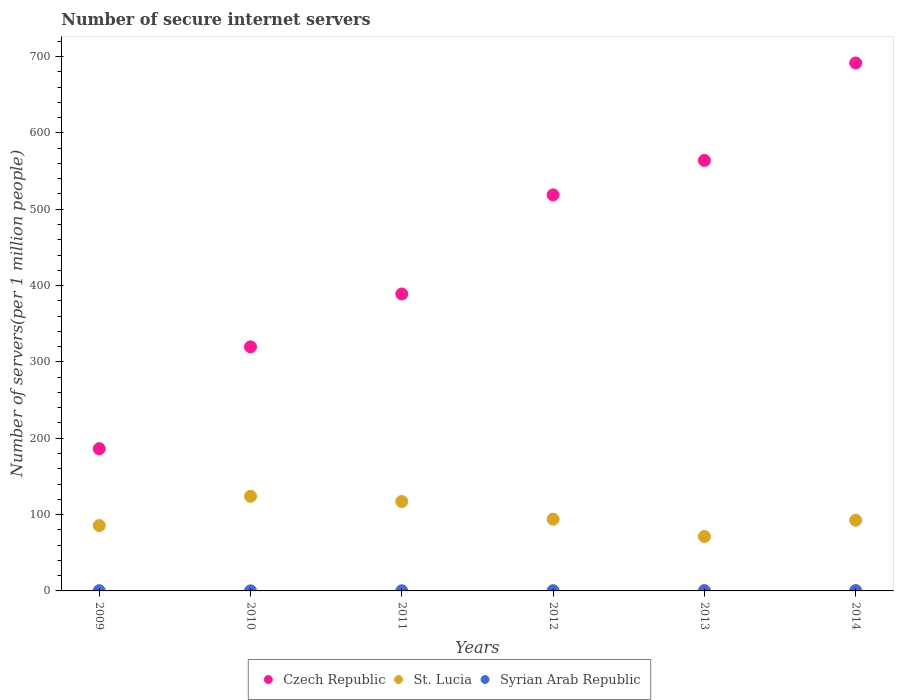Is the number of dotlines equal to the number of legend labels?
Provide a succinct answer. Yes. What is the number of secure internet servers in Czech Republic in 2013?
Offer a terse response. 563.9. Across all years, what is the maximum number of secure internet servers in Syrian Arab Republic?
Make the answer very short. 0.5. Across all years, what is the minimum number of secure internet servers in Syrian Arab Republic?
Your answer should be very brief. 0.1. In which year was the number of secure internet servers in Czech Republic maximum?
Your answer should be very brief. 2014. In which year was the number of secure internet servers in St. Lucia minimum?
Offer a terse response. 2013. What is the total number of secure internet servers in Czech Republic in the graph?
Offer a terse response. 2669.35. What is the difference between the number of secure internet servers in Czech Republic in 2011 and that in 2013?
Your response must be concise. -174.9. What is the difference between the number of secure internet servers in St. Lucia in 2014 and the number of secure internet servers in Czech Republic in 2010?
Ensure brevity in your answer.  -227.16. What is the average number of secure internet servers in St. Lucia per year?
Ensure brevity in your answer.  97.44. In the year 2014, what is the difference between the number of secure internet servers in St. Lucia and number of secure internet servers in Czech Republic?
Give a very brief answer. -599.02. What is the ratio of the number of secure internet servers in Syrian Arab Republic in 2012 to that in 2013?
Make the answer very short. 0.81. Is the number of secure internet servers in Czech Republic in 2009 less than that in 2014?
Your answer should be compact. Yes. What is the difference between the highest and the second highest number of secure internet servers in Czech Republic?
Your response must be concise. 127.69. What is the difference between the highest and the lowest number of secure internet servers in St. Lucia?
Offer a terse response. 52.71. In how many years, is the number of secure internet servers in Syrian Arab Republic greater than the average number of secure internet servers in Syrian Arab Republic taken over all years?
Ensure brevity in your answer.  4. Is the sum of the number of secure internet servers in Czech Republic in 2010 and 2011 greater than the maximum number of secure internet servers in Syrian Arab Republic across all years?
Your answer should be very brief. Yes. Is it the case that in every year, the sum of the number of secure internet servers in Czech Republic and number of secure internet servers in St. Lucia  is greater than the number of secure internet servers in Syrian Arab Republic?
Keep it short and to the point. Yes. Does the number of secure internet servers in Czech Republic monotonically increase over the years?
Provide a short and direct response. Yes. Is the number of secure internet servers in Syrian Arab Republic strictly less than the number of secure internet servers in St. Lucia over the years?
Provide a short and direct response. Yes. What is the difference between two consecutive major ticks on the Y-axis?
Offer a terse response. 100. Does the graph contain any zero values?
Offer a terse response. No. How many legend labels are there?
Give a very brief answer. 3. What is the title of the graph?
Offer a terse response. Number of secure internet servers. What is the label or title of the X-axis?
Your answer should be very brief. Years. What is the label or title of the Y-axis?
Provide a short and direct response. Number of servers(per 1 million people). What is the Number of servers(per 1 million people) of Czech Republic in 2009?
Offer a terse response. 186.33. What is the Number of servers(per 1 million people) of St. Lucia in 2009?
Your answer should be compact. 85.62. What is the Number of servers(per 1 million people) in Syrian Arab Republic in 2009?
Make the answer very short. 0.34. What is the Number of servers(per 1 million people) of Czech Republic in 2010?
Make the answer very short. 319.73. What is the Number of servers(per 1 million people) in St. Lucia in 2010?
Make the answer very short. 124.02. What is the Number of servers(per 1 million people) in Syrian Arab Republic in 2010?
Ensure brevity in your answer.  0.1. What is the Number of servers(per 1 million people) in Czech Republic in 2011?
Offer a very short reply. 389. What is the Number of servers(per 1 million people) of St. Lucia in 2011?
Offer a terse response. 117.14. What is the Number of servers(per 1 million people) in Syrian Arab Republic in 2011?
Provide a succinct answer. 0.24. What is the Number of servers(per 1 million people) of Czech Republic in 2012?
Your response must be concise. 518.8. What is the Number of servers(per 1 million people) of St. Lucia in 2012?
Keep it short and to the point. 93.98. What is the Number of servers(per 1 million people) of Syrian Arab Republic in 2012?
Your answer should be compact. 0.37. What is the Number of servers(per 1 million people) in Czech Republic in 2013?
Your answer should be very brief. 563.9. What is the Number of servers(per 1 million people) in St. Lucia in 2013?
Ensure brevity in your answer.  71.31. What is the Number of servers(per 1 million people) of Syrian Arab Republic in 2013?
Give a very brief answer. 0.46. What is the Number of servers(per 1 million people) of Czech Republic in 2014?
Keep it short and to the point. 691.59. What is the Number of servers(per 1 million people) in St. Lucia in 2014?
Make the answer very short. 92.57. What is the Number of servers(per 1 million people) in Syrian Arab Republic in 2014?
Give a very brief answer. 0.5. Across all years, what is the maximum Number of servers(per 1 million people) of Czech Republic?
Your response must be concise. 691.59. Across all years, what is the maximum Number of servers(per 1 million people) of St. Lucia?
Ensure brevity in your answer.  124.02. Across all years, what is the maximum Number of servers(per 1 million people) of Syrian Arab Republic?
Offer a terse response. 0.5. Across all years, what is the minimum Number of servers(per 1 million people) in Czech Republic?
Provide a succinct answer. 186.33. Across all years, what is the minimum Number of servers(per 1 million people) of St. Lucia?
Offer a terse response. 71.31. Across all years, what is the minimum Number of servers(per 1 million people) of Syrian Arab Republic?
Ensure brevity in your answer.  0.1. What is the total Number of servers(per 1 million people) of Czech Republic in the graph?
Offer a very short reply. 2669.35. What is the total Number of servers(per 1 million people) of St. Lucia in the graph?
Offer a very short reply. 584.63. What is the total Number of servers(per 1 million people) of Syrian Arab Republic in the graph?
Provide a short and direct response. 2. What is the difference between the Number of servers(per 1 million people) in Czech Republic in 2009 and that in 2010?
Your answer should be compact. -133.4. What is the difference between the Number of servers(per 1 million people) of St. Lucia in 2009 and that in 2010?
Give a very brief answer. -38.4. What is the difference between the Number of servers(per 1 million people) of Syrian Arab Republic in 2009 and that in 2010?
Give a very brief answer. 0.24. What is the difference between the Number of servers(per 1 million people) of Czech Republic in 2009 and that in 2011?
Offer a terse response. -202.67. What is the difference between the Number of servers(per 1 million people) in St. Lucia in 2009 and that in 2011?
Provide a short and direct response. -31.52. What is the difference between the Number of servers(per 1 million people) of Syrian Arab Republic in 2009 and that in 2011?
Provide a succinct answer. 0.1. What is the difference between the Number of servers(per 1 million people) of Czech Republic in 2009 and that in 2012?
Keep it short and to the point. -332.47. What is the difference between the Number of servers(per 1 million people) of St. Lucia in 2009 and that in 2012?
Offer a very short reply. -8.36. What is the difference between the Number of servers(per 1 million people) in Syrian Arab Republic in 2009 and that in 2012?
Your answer should be very brief. -0.03. What is the difference between the Number of servers(per 1 million people) in Czech Republic in 2009 and that in 2013?
Ensure brevity in your answer.  -377.57. What is the difference between the Number of servers(per 1 million people) in St. Lucia in 2009 and that in 2013?
Provide a short and direct response. 14.31. What is the difference between the Number of servers(per 1 million people) in Syrian Arab Republic in 2009 and that in 2013?
Your response must be concise. -0.12. What is the difference between the Number of servers(per 1 million people) of Czech Republic in 2009 and that in 2014?
Give a very brief answer. -505.26. What is the difference between the Number of servers(per 1 million people) in St. Lucia in 2009 and that in 2014?
Provide a short and direct response. -6.95. What is the difference between the Number of servers(per 1 million people) of Syrian Arab Republic in 2009 and that in 2014?
Offer a terse response. -0.16. What is the difference between the Number of servers(per 1 million people) in Czech Republic in 2010 and that in 2011?
Provide a succinct answer. -69.27. What is the difference between the Number of servers(per 1 million people) of St. Lucia in 2010 and that in 2011?
Your answer should be compact. 6.88. What is the difference between the Number of servers(per 1 million people) of Syrian Arab Republic in 2010 and that in 2011?
Ensure brevity in your answer.  -0.14. What is the difference between the Number of servers(per 1 million people) in Czech Republic in 2010 and that in 2012?
Ensure brevity in your answer.  -199.07. What is the difference between the Number of servers(per 1 million people) in St. Lucia in 2010 and that in 2012?
Offer a terse response. 30.04. What is the difference between the Number of servers(per 1 million people) of Syrian Arab Republic in 2010 and that in 2012?
Your response must be concise. -0.28. What is the difference between the Number of servers(per 1 million people) in Czech Republic in 2010 and that in 2013?
Provide a succinct answer. -244.17. What is the difference between the Number of servers(per 1 million people) in St. Lucia in 2010 and that in 2013?
Provide a succinct answer. 52.71. What is the difference between the Number of servers(per 1 million people) of Syrian Arab Republic in 2010 and that in 2013?
Keep it short and to the point. -0.36. What is the difference between the Number of servers(per 1 million people) in Czech Republic in 2010 and that in 2014?
Ensure brevity in your answer.  -371.86. What is the difference between the Number of servers(per 1 million people) of St. Lucia in 2010 and that in 2014?
Make the answer very short. 31.45. What is the difference between the Number of servers(per 1 million people) of Syrian Arab Republic in 2010 and that in 2014?
Offer a terse response. -0.4. What is the difference between the Number of servers(per 1 million people) in Czech Republic in 2011 and that in 2012?
Provide a short and direct response. -129.8. What is the difference between the Number of servers(per 1 million people) in St. Lucia in 2011 and that in 2012?
Provide a short and direct response. 23.16. What is the difference between the Number of servers(per 1 million people) of Syrian Arab Republic in 2011 and that in 2012?
Offer a terse response. -0.14. What is the difference between the Number of servers(per 1 million people) in Czech Republic in 2011 and that in 2013?
Offer a very short reply. -174.9. What is the difference between the Number of servers(per 1 million people) of St. Lucia in 2011 and that in 2013?
Keep it short and to the point. 45.83. What is the difference between the Number of servers(per 1 million people) in Syrian Arab Republic in 2011 and that in 2013?
Provide a short and direct response. -0.22. What is the difference between the Number of servers(per 1 million people) of Czech Republic in 2011 and that in 2014?
Offer a terse response. -302.59. What is the difference between the Number of servers(per 1 million people) in St. Lucia in 2011 and that in 2014?
Your answer should be very brief. 24.57. What is the difference between the Number of servers(per 1 million people) of Syrian Arab Republic in 2011 and that in 2014?
Your answer should be compact. -0.26. What is the difference between the Number of servers(per 1 million people) of Czech Republic in 2012 and that in 2013?
Provide a succinct answer. -45.1. What is the difference between the Number of servers(per 1 million people) of St. Lucia in 2012 and that in 2013?
Offer a terse response. 22.67. What is the difference between the Number of servers(per 1 million people) in Syrian Arab Republic in 2012 and that in 2013?
Your answer should be compact. -0.09. What is the difference between the Number of servers(per 1 million people) of Czech Republic in 2012 and that in 2014?
Provide a succinct answer. -172.79. What is the difference between the Number of servers(per 1 million people) in St. Lucia in 2012 and that in 2014?
Your response must be concise. 1.41. What is the difference between the Number of servers(per 1 million people) in Syrian Arab Republic in 2012 and that in 2014?
Provide a short and direct response. -0.12. What is the difference between the Number of servers(per 1 million people) in Czech Republic in 2013 and that in 2014?
Give a very brief answer. -127.69. What is the difference between the Number of servers(per 1 million people) of St. Lucia in 2013 and that in 2014?
Ensure brevity in your answer.  -21.26. What is the difference between the Number of servers(per 1 million people) of Syrian Arab Republic in 2013 and that in 2014?
Make the answer very short. -0.04. What is the difference between the Number of servers(per 1 million people) in Czech Republic in 2009 and the Number of servers(per 1 million people) in St. Lucia in 2010?
Ensure brevity in your answer.  62.31. What is the difference between the Number of servers(per 1 million people) of Czech Republic in 2009 and the Number of servers(per 1 million people) of Syrian Arab Republic in 2010?
Your response must be concise. 186.23. What is the difference between the Number of servers(per 1 million people) in St. Lucia in 2009 and the Number of servers(per 1 million people) in Syrian Arab Republic in 2010?
Your answer should be compact. 85.52. What is the difference between the Number of servers(per 1 million people) in Czech Republic in 2009 and the Number of servers(per 1 million people) in St. Lucia in 2011?
Provide a short and direct response. 69.19. What is the difference between the Number of servers(per 1 million people) in Czech Republic in 2009 and the Number of servers(per 1 million people) in Syrian Arab Republic in 2011?
Keep it short and to the point. 186.09. What is the difference between the Number of servers(per 1 million people) of St. Lucia in 2009 and the Number of servers(per 1 million people) of Syrian Arab Republic in 2011?
Make the answer very short. 85.38. What is the difference between the Number of servers(per 1 million people) in Czech Republic in 2009 and the Number of servers(per 1 million people) in St. Lucia in 2012?
Offer a terse response. 92.35. What is the difference between the Number of servers(per 1 million people) of Czech Republic in 2009 and the Number of servers(per 1 million people) of Syrian Arab Republic in 2012?
Your answer should be very brief. 185.95. What is the difference between the Number of servers(per 1 million people) in St. Lucia in 2009 and the Number of servers(per 1 million people) in Syrian Arab Republic in 2012?
Give a very brief answer. 85.25. What is the difference between the Number of servers(per 1 million people) in Czech Republic in 2009 and the Number of servers(per 1 million people) in St. Lucia in 2013?
Your answer should be compact. 115.02. What is the difference between the Number of servers(per 1 million people) in Czech Republic in 2009 and the Number of servers(per 1 million people) in Syrian Arab Republic in 2013?
Keep it short and to the point. 185.87. What is the difference between the Number of servers(per 1 million people) in St. Lucia in 2009 and the Number of servers(per 1 million people) in Syrian Arab Republic in 2013?
Your answer should be compact. 85.16. What is the difference between the Number of servers(per 1 million people) of Czech Republic in 2009 and the Number of servers(per 1 million people) of St. Lucia in 2014?
Your answer should be very brief. 93.76. What is the difference between the Number of servers(per 1 million people) in Czech Republic in 2009 and the Number of servers(per 1 million people) in Syrian Arab Republic in 2014?
Your answer should be very brief. 185.83. What is the difference between the Number of servers(per 1 million people) of St. Lucia in 2009 and the Number of servers(per 1 million people) of Syrian Arab Republic in 2014?
Give a very brief answer. 85.12. What is the difference between the Number of servers(per 1 million people) in Czech Republic in 2010 and the Number of servers(per 1 million people) in St. Lucia in 2011?
Offer a terse response. 202.6. What is the difference between the Number of servers(per 1 million people) of Czech Republic in 2010 and the Number of servers(per 1 million people) of Syrian Arab Republic in 2011?
Offer a very short reply. 319.49. What is the difference between the Number of servers(per 1 million people) of St. Lucia in 2010 and the Number of servers(per 1 million people) of Syrian Arab Republic in 2011?
Make the answer very short. 123.78. What is the difference between the Number of servers(per 1 million people) of Czech Republic in 2010 and the Number of servers(per 1 million people) of St. Lucia in 2012?
Make the answer very short. 225.75. What is the difference between the Number of servers(per 1 million people) in Czech Republic in 2010 and the Number of servers(per 1 million people) in Syrian Arab Republic in 2012?
Keep it short and to the point. 319.36. What is the difference between the Number of servers(per 1 million people) of St. Lucia in 2010 and the Number of servers(per 1 million people) of Syrian Arab Republic in 2012?
Your response must be concise. 123.64. What is the difference between the Number of servers(per 1 million people) of Czech Republic in 2010 and the Number of servers(per 1 million people) of St. Lucia in 2013?
Your answer should be compact. 248.42. What is the difference between the Number of servers(per 1 million people) in Czech Republic in 2010 and the Number of servers(per 1 million people) in Syrian Arab Republic in 2013?
Give a very brief answer. 319.27. What is the difference between the Number of servers(per 1 million people) of St. Lucia in 2010 and the Number of servers(per 1 million people) of Syrian Arab Republic in 2013?
Provide a succinct answer. 123.56. What is the difference between the Number of servers(per 1 million people) in Czech Republic in 2010 and the Number of servers(per 1 million people) in St. Lucia in 2014?
Your answer should be very brief. 227.16. What is the difference between the Number of servers(per 1 million people) in Czech Republic in 2010 and the Number of servers(per 1 million people) in Syrian Arab Republic in 2014?
Ensure brevity in your answer.  319.24. What is the difference between the Number of servers(per 1 million people) in St. Lucia in 2010 and the Number of servers(per 1 million people) in Syrian Arab Republic in 2014?
Make the answer very short. 123.52. What is the difference between the Number of servers(per 1 million people) of Czech Republic in 2011 and the Number of servers(per 1 million people) of St. Lucia in 2012?
Provide a short and direct response. 295.02. What is the difference between the Number of servers(per 1 million people) in Czech Republic in 2011 and the Number of servers(per 1 million people) in Syrian Arab Republic in 2012?
Your answer should be very brief. 388.63. What is the difference between the Number of servers(per 1 million people) in St. Lucia in 2011 and the Number of servers(per 1 million people) in Syrian Arab Republic in 2012?
Offer a terse response. 116.76. What is the difference between the Number of servers(per 1 million people) in Czech Republic in 2011 and the Number of servers(per 1 million people) in St. Lucia in 2013?
Make the answer very short. 317.69. What is the difference between the Number of servers(per 1 million people) in Czech Republic in 2011 and the Number of servers(per 1 million people) in Syrian Arab Republic in 2013?
Make the answer very short. 388.54. What is the difference between the Number of servers(per 1 million people) of St. Lucia in 2011 and the Number of servers(per 1 million people) of Syrian Arab Republic in 2013?
Offer a terse response. 116.68. What is the difference between the Number of servers(per 1 million people) of Czech Republic in 2011 and the Number of servers(per 1 million people) of St. Lucia in 2014?
Your response must be concise. 296.43. What is the difference between the Number of servers(per 1 million people) of Czech Republic in 2011 and the Number of servers(per 1 million people) of Syrian Arab Republic in 2014?
Ensure brevity in your answer.  388.51. What is the difference between the Number of servers(per 1 million people) in St. Lucia in 2011 and the Number of servers(per 1 million people) in Syrian Arab Republic in 2014?
Offer a very short reply. 116.64. What is the difference between the Number of servers(per 1 million people) in Czech Republic in 2012 and the Number of servers(per 1 million people) in St. Lucia in 2013?
Offer a very short reply. 447.49. What is the difference between the Number of servers(per 1 million people) of Czech Republic in 2012 and the Number of servers(per 1 million people) of Syrian Arab Republic in 2013?
Ensure brevity in your answer.  518.34. What is the difference between the Number of servers(per 1 million people) of St. Lucia in 2012 and the Number of servers(per 1 million people) of Syrian Arab Republic in 2013?
Provide a succinct answer. 93.52. What is the difference between the Number of servers(per 1 million people) in Czech Republic in 2012 and the Number of servers(per 1 million people) in St. Lucia in 2014?
Your response must be concise. 426.23. What is the difference between the Number of servers(per 1 million people) of Czech Republic in 2012 and the Number of servers(per 1 million people) of Syrian Arab Republic in 2014?
Give a very brief answer. 518.3. What is the difference between the Number of servers(per 1 million people) of St. Lucia in 2012 and the Number of servers(per 1 million people) of Syrian Arab Republic in 2014?
Give a very brief answer. 93.48. What is the difference between the Number of servers(per 1 million people) of Czech Republic in 2013 and the Number of servers(per 1 million people) of St. Lucia in 2014?
Give a very brief answer. 471.33. What is the difference between the Number of servers(per 1 million people) of Czech Republic in 2013 and the Number of servers(per 1 million people) of Syrian Arab Republic in 2014?
Your response must be concise. 563.4. What is the difference between the Number of servers(per 1 million people) in St. Lucia in 2013 and the Number of servers(per 1 million people) in Syrian Arab Republic in 2014?
Your response must be concise. 70.81. What is the average Number of servers(per 1 million people) in Czech Republic per year?
Make the answer very short. 444.89. What is the average Number of servers(per 1 million people) of St. Lucia per year?
Offer a terse response. 97.44. What is the average Number of servers(per 1 million people) in Syrian Arab Republic per year?
Keep it short and to the point. 0.33. In the year 2009, what is the difference between the Number of servers(per 1 million people) of Czech Republic and Number of servers(per 1 million people) of St. Lucia?
Give a very brief answer. 100.71. In the year 2009, what is the difference between the Number of servers(per 1 million people) in Czech Republic and Number of servers(per 1 million people) in Syrian Arab Republic?
Your answer should be very brief. 185.99. In the year 2009, what is the difference between the Number of servers(per 1 million people) of St. Lucia and Number of servers(per 1 million people) of Syrian Arab Republic?
Keep it short and to the point. 85.28. In the year 2010, what is the difference between the Number of servers(per 1 million people) of Czech Republic and Number of servers(per 1 million people) of St. Lucia?
Give a very brief answer. 195.72. In the year 2010, what is the difference between the Number of servers(per 1 million people) of Czech Republic and Number of servers(per 1 million people) of Syrian Arab Republic?
Ensure brevity in your answer.  319.64. In the year 2010, what is the difference between the Number of servers(per 1 million people) of St. Lucia and Number of servers(per 1 million people) of Syrian Arab Republic?
Ensure brevity in your answer.  123.92. In the year 2011, what is the difference between the Number of servers(per 1 million people) of Czech Republic and Number of servers(per 1 million people) of St. Lucia?
Ensure brevity in your answer.  271.87. In the year 2011, what is the difference between the Number of servers(per 1 million people) of Czech Republic and Number of servers(per 1 million people) of Syrian Arab Republic?
Offer a very short reply. 388.76. In the year 2011, what is the difference between the Number of servers(per 1 million people) in St. Lucia and Number of servers(per 1 million people) in Syrian Arab Republic?
Provide a succinct answer. 116.9. In the year 2012, what is the difference between the Number of servers(per 1 million people) in Czech Republic and Number of servers(per 1 million people) in St. Lucia?
Provide a short and direct response. 424.82. In the year 2012, what is the difference between the Number of servers(per 1 million people) in Czech Republic and Number of servers(per 1 million people) in Syrian Arab Republic?
Provide a succinct answer. 518.43. In the year 2012, what is the difference between the Number of servers(per 1 million people) in St. Lucia and Number of servers(per 1 million people) in Syrian Arab Republic?
Offer a terse response. 93.61. In the year 2013, what is the difference between the Number of servers(per 1 million people) in Czech Republic and Number of servers(per 1 million people) in St. Lucia?
Keep it short and to the point. 492.59. In the year 2013, what is the difference between the Number of servers(per 1 million people) in Czech Republic and Number of servers(per 1 million people) in Syrian Arab Republic?
Ensure brevity in your answer.  563.44. In the year 2013, what is the difference between the Number of servers(per 1 million people) in St. Lucia and Number of servers(per 1 million people) in Syrian Arab Republic?
Your response must be concise. 70.85. In the year 2014, what is the difference between the Number of servers(per 1 million people) of Czech Republic and Number of servers(per 1 million people) of St. Lucia?
Your response must be concise. 599.02. In the year 2014, what is the difference between the Number of servers(per 1 million people) of Czech Republic and Number of servers(per 1 million people) of Syrian Arab Republic?
Provide a short and direct response. 691.09. In the year 2014, what is the difference between the Number of servers(per 1 million people) in St. Lucia and Number of servers(per 1 million people) in Syrian Arab Republic?
Provide a short and direct response. 92.07. What is the ratio of the Number of servers(per 1 million people) of Czech Republic in 2009 to that in 2010?
Your answer should be compact. 0.58. What is the ratio of the Number of servers(per 1 million people) of St. Lucia in 2009 to that in 2010?
Your response must be concise. 0.69. What is the ratio of the Number of servers(per 1 million people) of Syrian Arab Republic in 2009 to that in 2010?
Provide a short and direct response. 3.53. What is the ratio of the Number of servers(per 1 million people) of Czech Republic in 2009 to that in 2011?
Provide a short and direct response. 0.48. What is the ratio of the Number of servers(per 1 million people) of St. Lucia in 2009 to that in 2011?
Offer a terse response. 0.73. What is the ratio of the Number of servers(per 1 million people) in Syrian Arab Republic in 2009 to that in 2011?
Offer a terse response. 1.43. What is the ratio of the Number of servers(per 1 million people) in Czech Republic in 2009 to that in 2012?
Keep it short and to the point. 0.36. What is the ratio of the Number of servers(per 1 million people) in St. Lucia in 2009 to that in 2012?
Provide a succinct answer. 0.91. What is the ratio of the Number of servers(per 1 million people) of Syrian Arab Republic in 2009 to that in 2012?
Offer a terse response. 0.91. What is the ratio of the Number of servers(per 1 million people) in Czech Republic in 2009 to that in 2013?
Provide a succinct answer. 0.33. What is the ratio of the Number of servers(per 1 million people) in St. Lucia in 2009 to that in 2013?
Offer a terse response. 1.2. What is the ratio of the Number of servers(per 1 million people) of Syrian Arab Republic in 2009 to that in 2013?
Make the answer very short. 0.74. What is the ratio of the Number of servers(per 1 million people) in Czech Republic in 2009 to that in 2014?
Offer a very short reply. 0.27. What is the ratio of the Number of servers(per 1 million people) in St. Lucia in 2009 to that in 2014?
Provide a short and direct response. 0.92. What is the ratio of the Number of servers(per 1 million people) in Syrian Arab Republic in 2009 to that in 2014?
Your answer should be compact. 0.69. What is the ratio of the Number of servers(per 1 million people) of Czech Republic in 2010 to that in 2011?
Your response must be concise. 0.82. What is the ratio of the Number of servers(per 1 million people) in St. Lucia in 2010 to that in 2011?
Provide a succinct answer. 1.06. What is the ratio of the Number of servers(per 1 million people) in Syrian Arab Republic in 2010 to that in 2011?
Ensure brevity in your answer.  0.41. What is the ratio of the Number of servers(per 1 million people) of Czech Republic in 2010 to that in 2012?
Your response must be concise. 0.62. What is the ratio of the Number of servers(per 1 million people) in St. Lucia in 2010 to that in 2012?
Make the answer very short. 1.32. What is the ratio of the Number of servers(per 1 million people) of Syrian Arab Republic in 2010 to that in 2012?
Provide a short and direct response. 0.26. What is the ratio of the Number of servers(per 1 million people) of Czech Republic in 2010 to that in 2013?
Give a very brief answer. 0.57. What is the ratio of the Number of servers(per 1 million people) in St. Lucia in 2010 to that in 2013?
Make the answer very short. 1.74. What is the ratio of the Number of servers(per 1 million people) of Syrian Arab Republic in 2010 to that in 2013?
Offer a very short reply. 0.21. What is the ratio of the Number of servers(per 1 million people) of Czech Republic in 2010 to that in 2014?
Keep it short and to the point. 0.46. What is the ratio of the Number of servers(per 1 million people) in St. Lucia in 2010 to that in 2014?
Give a very brief answer. 1.34. What is the ratio of the Number of servers(per 1 million people) of Syrian Arab Republic in 2010 to that in 2014?
Keep it short and to the point. 0.19. What is the ratio of the Number of servers(per 1 million people) in Czech Republic in 2011 to that in 2012?
Offer a very short reply. 0.75. What is the ratio of the Number of servers(per 1 million people) of St. Lucia in 2011 to that in 2012?
Offer a terse response. 1.25. What is the ratio of the Number of servers(per 1 million people) in Syrian Arab Republic in 2011 to that in 2012?
Keep it short and to the point. 0.64. What is the ratio of the Number of servers(per 1 million people) of Czech Republic in 2011 to that in 2013?
Provide a short and direct response. 0.69. What is the ratio of the Number of servers(per 1 million people) of St. Lucia in 2011 to that in 2013?
Your answer should be compact. 1.64. What is the ratio of the Number of servers(per 1 million people) of Syrian Arab Republic in 2011 to that in 2013?
Offer a very short reply. 0.52. What is the ratio of the Number of servers(per 1 million people) in Czech Republic in 2011 to that in 2014?
Your answer should be very brief. 0.56. What is the ratio of the Number of servers(per 1 million people) in St. Lucia in 2011 to that in 2014?
Ensure brevity in your answer.  1.27. What is the ratio of the Number of servers(per 1 million people) of Syrian Arab Republic in 2011 to that in 2014?
Your answer should be compact. 0.48. What is the ratio of the Number of servers(per 1 million people) of St. Lucia in 2012 to that in 2013?
Keep it short and to the point. 1.32. What is the ratio of the Number of servers(per 1 million people) in Syrian Arab Republic in 2012 to that in 2013?
Give a very brief answer. 0.81. What is the ratio of the Number of servers(per 1 million people) of Czech Republic in 2012 to that in 2014?
Make the answer very short. 0.75. What is the ratio of the Number of servers(per 1 million people) in St. Lucia in 2012 to that in 2014?
Give a very brief answer. 1.02. What is the ratio of the Number of servers(per 1 million people) in Syrian Arab Republic in 2012 to that in 2014?
Your answer should be compact. 0.75. What is the ratio of the Number of servers(per 1 million people) in Czech Republic in 2013 to that in 2014?
Keep it short and to the point. 0.82. What is the ratio of the Number of servers(per 1 million people) in St. Lucia in 2013 to that in 2014?
Give a very brief answer. 0.77. What is the ratio of the Number of servers(per 1 million people) of Syrian Arab Republic in 2013 to that in 2014?
Offer a terse response. 0.92. What is the difference between the highest and the second highest Number of servers(per 1 million people) of Czech Republic?
Your response must be concise. 127.69. What is the difference between the highest and the second highest Number of servers(per 1 million people) of St. Lucia?
Provide a succinct answer. 6.88. What is the difference between the highest and the second highest Number of servers(per 1 million people) in Syrian Arab Republic?
Your answer should be very brief. 0.04. What is the difference between the highest and the lowest Number of servers(per 1 million people) of Czech Republic?
Give a very brief answer. 505.26. What is the difference between the highest and the lowest Number of servers(per 1 million people) of St. Lucia?
Your answer should be very brief. 52.71. What is the difference between the highest and the lowest Number of servers(per 1 million people) in Syrian Arab Republic?
Your response must be concise. 0.4. 